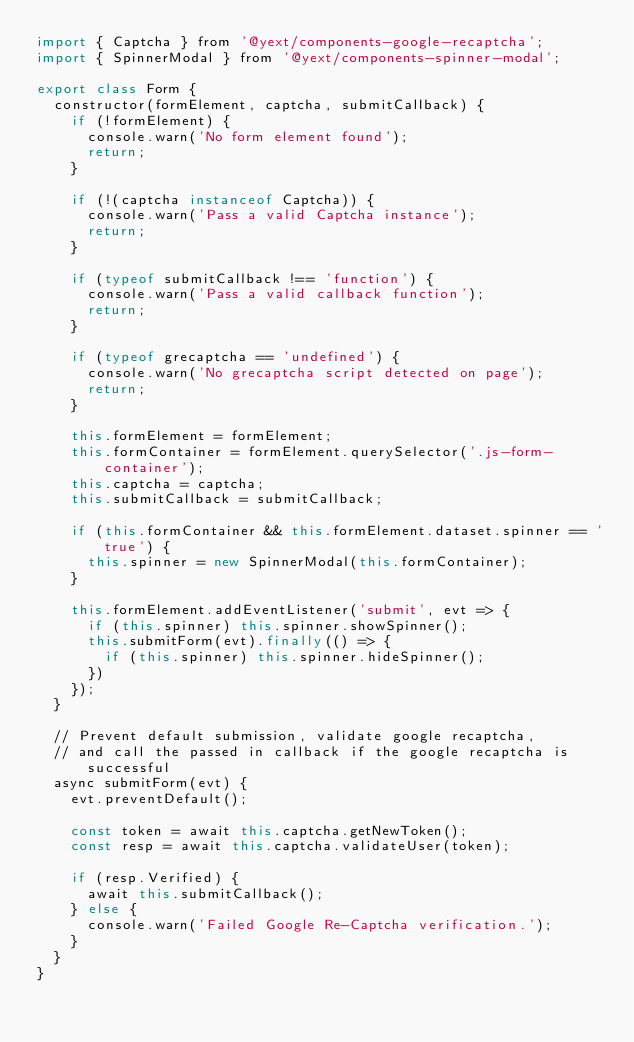Convert code to text. <code><loc_0><loc_0><loc_500><loc_500><_JavaScript_>import { Captcha } from '@yext/components-google-recaptcha';
import { SpinnerModal } from '@yext/components-spinner-modal';

export class Form {
  constructor(formElement, captcha, submitCallback) {
    if (!formElement) {
      console.warn('No form element found');
      return;
    }

    if (!(captcha instanceof Captcha)) {
      console.warn('Pass a valid Captcha instance');
      return;
    }

    if (typeof submitCallback !== 'function') {
      console.warn('Pass a valid callback function');
      return;
    }

    if (typeof grecaptcha == 'undefined') {
      console.warn('No grecaptcha script detected on page');
      return;
    }

    this.formElement = formElement;
    this.formContainer = formElement.querySelector('.js-form-container');
    this.captcha = captcha;
    this.submitCallback = submitCallback;

    if (this.formContainer && this.formElement.dataset.spinner == 'true') {
      this.spinner = new SpinnerModal(this.formContainer);
    }

    this.formElement.addEventListener('submit', evt => {
      if (this.spinner) this.spinner.showSpinner();
      this.submitForm(evt).finally(() => {
        if (this.spinner) this.spinner.hideSpinner();
      })
    });
  }

  // Prevent default submission, validate google recaptcha,
  // and call the passed in callback if the google recaptcha is successful
  async submitForm(evt) {
    evt.preventDefault();

    const token = await this.captcha.getNewToken();
    const resp = await this.captcha.validateUser(token);

    if (resp.Verified) {
      await this.submitCallback();
    } else {
      console.warn('Failed Google Re-Captcha verification.');
    }
  }
}
</code> 